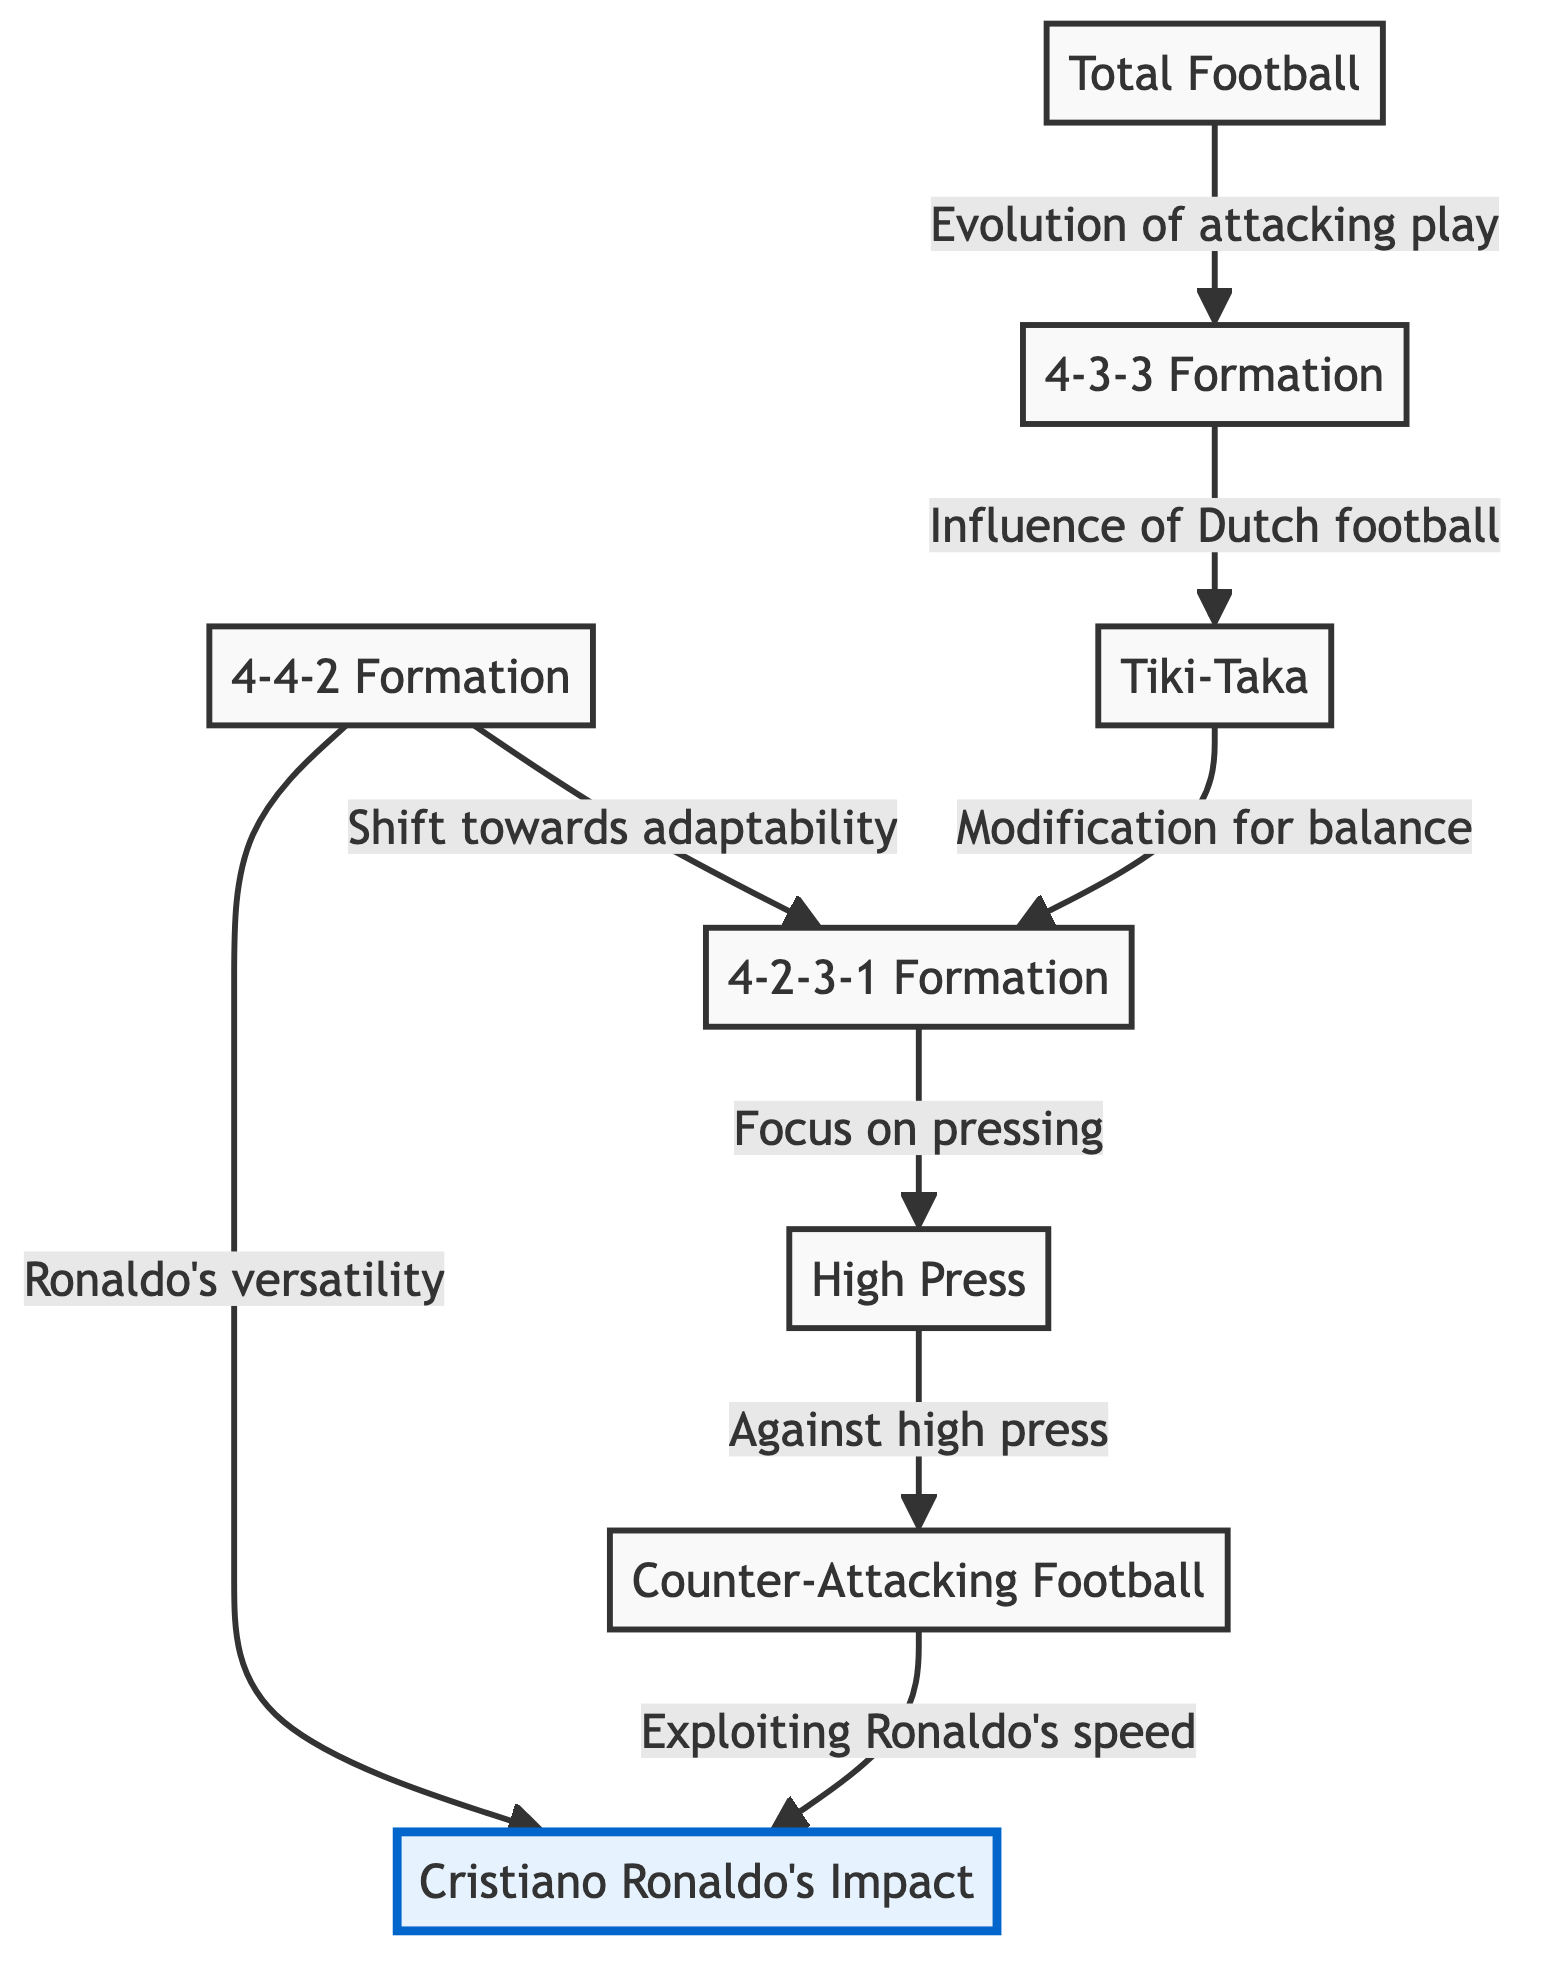What is the ID of the 4-3-3 Formation node? The node for the 4-3-3 Formation is labeled with the ID "2" as indicated in the data provided.
Answer: 2 How many formations are shown in the diagram? There are a total of 8 nodes listed in the data, and they all represent different formations or tactical concepts, which includes various formations.
Answer: 8 What tactical change is associated with the edge from the 4-4-2 Formation to the 4-2-3-1 Formation? The edge indicates "Shift towards adaptability," which describes the transition in team strategies that allowed for more flexible formations starting in the mid-2000s.
Answer: Shift towards adaptability Which formation is influenced by Total Football? The edge from Total Football points to the 4-3-3 Formation, indicating that Total Football concepts influenced the development of 4-3-3, focusing on the evolution of attacking play.
Answer: 4-3-3 Formation How does the Counter-Attacking Football utilize Cristiano Ronaldo's skills? The directed edge shows that Counter-Attacking Football leverages Ronaldo's speed and skill to enhance its effectiveness in quick transitions after regaining possession, demonstrating a tactical synergy.
Answer: Exploiting Ronaldo's speed Which formation primarily facilitated pressing strategies according to the diagram? The diagram has a directed edge from the 4-2-3-1 Formation to High Press, indicating that the 4-2-3-1 was specifically used for efficient pressing strategies.
Answer: 4-2-3-1 Formation What is the relationship between Tiki-Taka and the 4-2-3-1 Formation? The directed edge from Tiki-Taka to the 4-2-3-1 indicates a "Modification for balance," signifying that the limitations of Tiki-Taka led to a resurgence of flexible formations like the 4-2-3-1.
Answer: Modification for balance Which node has the most outgoing edges? To find this, we need to count the outgoing connections from each node. The High Press node has one outgoing edge to Counter-Attacking Football and 4-2-3-1 has three outgoing edges, making it the node with the most outgoing connections.
Answer: 4-2-3-1 Formation How is Cristiano Ronaldo's impact connected to the formations in the diagram? There are two directed edges leading to Cristiano Ronaldo's Impact: one connects from 4-4-2 Formation emphasizing Ronaldo’s versatility and the other from Counter-Attacking Football highlighting the exploitation of his speed and skill, showing how tactics evolved around him.
Answer: Ronaldo's versatility and Exploiting Ronaldo's speed 